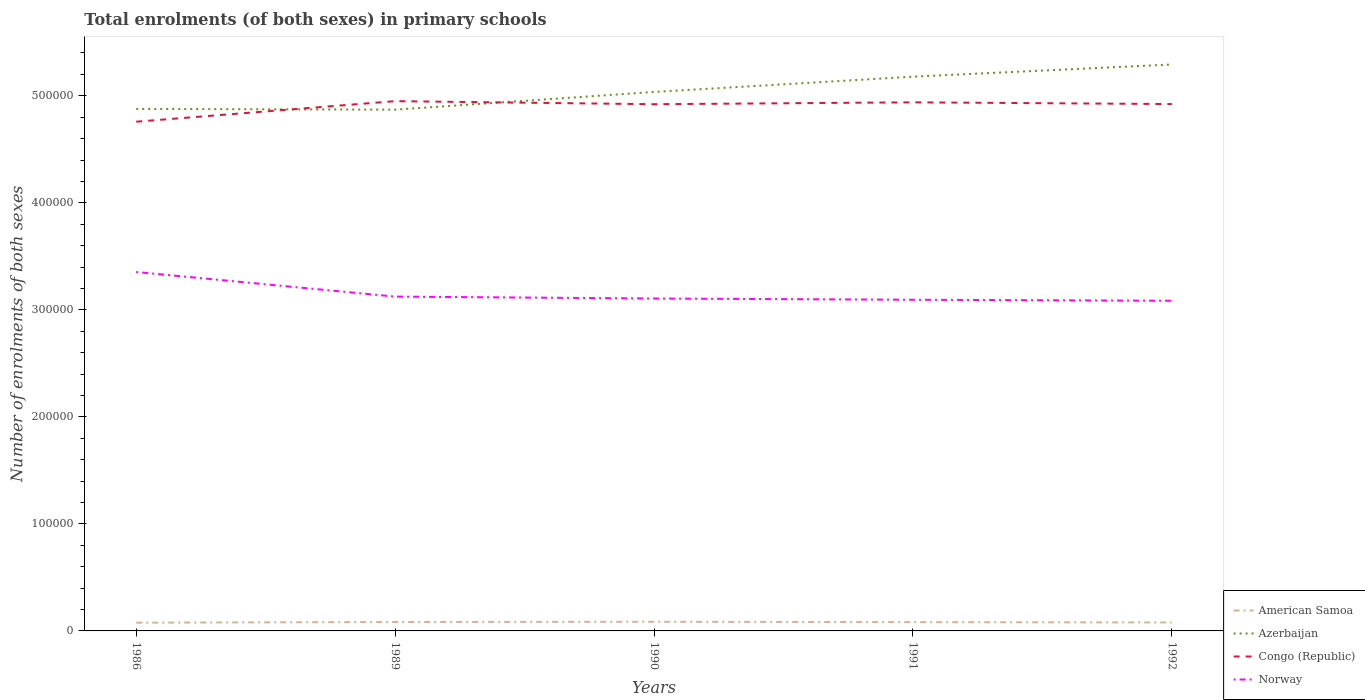Is the number of lines equal to the number of legend labels?
Ensure brevity in your answer.  Yes. Across all years, what is the maximum number of enrolments in primary schools in American Samoa?
Provide a succinct answer. 7704. What is the total number of enrolments in primary schools in Azerbaijan in the graph?
Ensure brevity in your answer.  -3.01e+04. What is the difference between the highest and the second highest number of enrolments in primary schools in American Samoa?
Keep it short and to the point. 870. Is the number of enrolments in primary schools in Congo (Republic) strictly greater than the number of enrolments in primary schools in Azerbaijan over the years?
Your response must be concise. No. How many lines are there?
Your response must be concise. 4. Where does the legend appear in the graph?
Offer a very short reply. Bottom right. How many legend labels are there?
Offer a terse response. 4. What is the title of the graph?
Your answer should be compact. Total enrolments (of both sexes) in primary schools. What is the label or title of the X-axis?
Provide a succinct answer. Years. What is the label or title of the Y-axis?
Give a very brief answer. Number of enrolments of both sexes. What is the Number of enrolments of both sexes in American Samoa in 1986?
Your answer should be very brief. 7704. What is the Number of enrolments of both sexes in Azerbaijan in 1986?
Your answer should be very brief. 4.88e+05. What is the Number of enrolments of both sexes of Congo (Republic) in 1986?
Your response must be concise. 4.76e+05. What is the Number of enrolments of both sexes of Norway in 1986?
Your response must be concise. 3.35e+05. What is the Number of enrolments of both sexes of American Samoa in 1989?
Give a very brief answer. 8308. What is the Number of enrolments of both sexes of Azerbaijan in 1989?
Ensure brevity in your answer.  4.87e+05. What is the Number of enrolments of both sexes of Congo (Republic) in 1989?
Provide a succinct answer. 4.95e+05. What is the Number of enrolments of both sexes in Norway in 1989?
Keep it short and to the point. 3.12e+05. What is the Number of enrolments of both sexes in American Samoa in 1990?
Offer a very short reply. 8574. What is the Number of enrolments of both sexes of Azerbaijan in 1990?
Keep it short and to the point. 5.04e+05. What is the Number of enrolments of both sexes of Congo (Republic) in 1990?
Provide a succinct answer. 4.92e+05. What is the Number of enrolments of both sexes in Norway in 1990?
Offer a terse response. 3.11e+05. What is the Number of enrolments of both sexes in American Samoa in 1991?
Ensure brevity in your answer.  8200. What is the Number of enrolments of both sexes of Azerbaijan in 1991?
Offer a terse response. 5.18e+05. What is the Number of enrolments of both sexes in Congo (Republic) in 1991?
Your response must be concise. 4.94e+05. What is the Number of enrolments of both sexes of Norway in 1991?
Offer a terse response. 3.09e+05. What is the Number of enrolments of both sexes of American Samoa in 1992?
Offer a very short reply. 7884. What is the Number of enrolments of both sexes in Azerbaijan in 1992?
Make the answer very short. 5.29e+05. What is the Number of enrolments of both sexes of Congo (Republic) in 1992?
Ensure brevity in your answer.  4.92e+05. What is the Number of enrolments of both sexes of Norway in 1992?
Your answer should be compact. 3.09e+05. Across all years, what is the maximum Number of enrolments of both sexes of American Samoa?
Make the answer very short. 8574. Across all years, what is the maximum Number of enrolments of both sexes in Azerbaijan?
Make the answer very short. 5.29e+05. Across all years, what is the maximum Number of enrolments of both sexes of Congo (Republic)?
Give a very brief answer. 4.95e+05. Across all years, what is the maximum Number of enrolments of both sexes in Norway?
Give a very brief answer. 3.35e+05. Across all years, what is the minimum Number of enrolments of both sexes in American Samoa?
Offer a terse response. 7704. Across all years, what is the minimum Number of enrolments of both sexes in Azerbaijan?
Your answer should be compact. 4.87e+05. Across all years, what is the minimum Number of enrolments of both sexes in Congo (Republic)?
Offer a very short reply. 4.76e+05. Across all years, what is the minimum Number of enrolments of both sexes in Norway?
Your answer should be compact. 3.09e+05. What is the total Number of enrolments of both sexes of American Samoa in the graph?
Your answer should be compact. 4.07e+04. What is the total Number of enrolments of both sexes in Azerbaijan in the graph?
Offer a very short reply. 2.53e+06. What is the total Number of enrolments of both sexes of Congo (Republic) in the graph?
Offer a very short reply. 2.45e+06. What is the total Number of enrolments of both sexes in Norway in the graph?
Offer a very short reply. 1.58e+06. What is the difference between the Number of enrolments of both sexes in American Samoa in 1986 and that in 1989?
Ensure brevity in your answer.  -604. What is the difference between the Number of enrolments of both sexes in Azerbaijan in 1986 and that in 1989?
Your answer should be compact. 695. What is the difference between the Number of enrolments of both sexes in Congo (Republic) in 1986 and that in 1989?
Keep it short and to the point. -1.92e+04. What is the difference between the Number of enrolments of both sexes of Norway in 1986 and that in 1989?
Offer a very short reply. 2.30e+04. What is the difference between the Number of enrolments of both sexes of American Samoa in 1986 and that in 1990?
Give a very brief answer. -870. What is the difference between the Number of enrolments of both sexes in Azerbaijan in 1986 and that in 1990?
Your answer should be compact. -1.58e+04. What is the difference between the Number of enrolments of both sexes of Congo (Republic) in 1986 and that in 1990?
Offer a very short reply. -1.63e+04. What is the difference between the Number of enrolments of both sexes of Norway in 1986 and that in 1990?
Your response must be concise. 2.48e+04. What is the difference between the Number of enrolments of both sexes in American Samoa in 1986 and that in 1991?
Offer a terse response. -496. What is the difference between the Number of enrolments of both sexes in Azerbaijan in 1986 and that in 1991?
Your response must be concise. -3.01e+04. What is the difference between the Number of enrolments of both sexes in Congo (Republic) in 1986 and that in 1991?
Ensure brevity in your answer.  -1.81e+04. What is the difference between the Number of enrolments of both sexes in Norway in 1986 and that in 1991?
Ensure brevity in your answer.  2.59e+04. What is the difference between the Number of enrolments of both sexes of American Samoa in 1986 and that in 1992?
Your answer should be very brief. -180. What is the difference between the Number of enrolments of both sexes of Azerbaijan in 1986 and that in 1992?
Give a very brief answer. -4.15e+04. What is the difference between the Number of enrolments of both sexes of Congo (Republic) in 1986 and that in 1992?
Give a very brief answer. -1.65e+04. What is the difference between the Number of enrolments of both sexes of Norway in 1986 and that in 1992?
Your answer should be compact. 2.69e+04. What is the difference between the Number of enrolments of both sexes of American Samoa in 1989 and that in 1990?
Keep it short and to the point. -266. What is the difference between the Number of enrolments of both sexes in Azerbaijan in 1989 and that in 1990?
Provide a succinct answer. -1.65e+04. What is the difference between the Number of enrolments of both sexes in Congo (Republic) in 1989 and that in 1990?
Your answer should be very brief. 2872. What is the difference between the Number of enrolments of both sexes in Norway in 1989 and that in 1990?
Your answer should be compact. 1784. What is the difference between the Number of enrolments of both sexes of American Samoa in 1989 and that in 1991?
Offer a very short reply. 108. What is the difference between the Number of enrolments of both sexes in Azerbaijan in 1989 and that in 1991?
Provide a short and direct response. -3.08e+04. What is the difference between the Number of enrolments of both sexes in Congo (Republic) in 1989 and that in 1991?
Ensure brevity in your answer.  1097. What is the difference between the Number of enrolments of both sexes in Norway in 1989 and that in 1991?
Your response must be concise. 2952. What is the difference between the Number of enrolments of both sexes in American Samoa in 1989 and that in 1992?
Provide a short and direct response. 424. What is the difference between the Number of enrolments of both sexes of Azerbaijan in 1989 and that in 1992?
Your answer should be very brief. -4.22e+04. What is the difference between the Number of enrolments of both sexes of Congo (Republic) in 1989 and that in 1992?
Provide a succinct answer. 2729. What is the difference between the Number of enrolments of both sexes of Norway in 1989 and that in 1992?
Your answer should be compact. 3868. What is the difference between the Number of enrolments of both sexes of American Samoa in 1990 and that in 1991?
Give a very brief answer. 374. What is the difference between the Number of enrolments of both sexes of Azerbaijan in 1990 and that in 1991?
Your response must be concise. -1.43e+04. What is the difference between the Number of enrolments of both sexes in Congo (Republic) in 1990 and that in 1991?
Your answer should be compact. -1775. What is the difference between the Number of enrolments of both sexes in Norway in 1990 and that in 1991?
Give a very brief answer. 1168. What is the difference between the Number of enrolments of both sexes in American Samoa in 1990 and that in 1992?
Make the answer very short. 690. What is the difference between the Number of enrolments of both sexes in Azerbaijan in 1990 and that in 1992?
Your response must be concise. -2.57e+04. What is the difference between the Number of enrolments of both sexes in Congo (Republic) in 1990 and that in 1992?
Offer a terse response. -143. What is the difference between the Number of enrolments of both sexes of Norway in 1990 and that in 1992?
Offer a terse response. 2084. What is the difference between the Number of enrolments of both sexes in American Samoa in 1991 and that in 1992?
Your answer should be compact. 316. What is the difference between the Number of enrolments of both sexes of Azerbaijan in 1991 and that in 1992?
Provide a short and direct response. -1.14e+04. What is the difference between the Number of enrolments of both sexes of Congo (Republic) in 1991 and that in 1992?
Offer a very short reply. 1632. What is the difference between the Number of enrolments of both sexes in Norway in 1991 and that in 1992?
Offer a terse response. 916. What is the difference between the Number of enrolments of both sexes of American Samoa in 1986 and the Number of enrolments of both sexes of Azerbaijan in 1989?
Keep it short and to the point. -4.79e+05. What is the difference between the Number of enrolments of both sexes in American Samoa in 1986 and the Number of enrolments of both sexes in Congo (Republic) in 1989?
Give a very brief answer. -4.87e+05. What is the difference between the Number of enrolments of both sexes of American Samoa in 1986 and the Number of enrolments of both sexes of Norway in 1989?
Offer a very short reply. -3.05e+05. What is the difference between the Number of enrolments of both sexes of Azerbaijan in 1986 and the Number of enrolments of both sexes of Congo (Republic) in 1989?
Your answer should be very brief. -7267. What is the difference between the Number of enrolments of both sexes of Azerbaijan in 1986 and the Number of enrolments of both sexes of Norway in 1989?
Your response must be concise. 1.75e+05. What is the difference between the Number of enrolments of both sexes in Congo (Republic) in 1986 and the Number of enrolments of both sexes in Norway in 1989?
Give a very brief answer. 1.63e+05. What is the difference between the Number of enrolments of both sexes in American Samoa in 1986 and the Number of enrolments of both sexes in Azerbaijan in 1990?
Provide a succinct answer. -4.96e+05. What is the difference between the Number of enrolments of both sexes in American Samoa in 1986 and the Number of enrolments of both sexes in Congo (Republic) in 1990?
Provide a succinct answer. -4.84e+05. What is the difference between the Number of enrolments of both sexes in American Samoa in 1986 and the Number of enrolments of both sexes in Norway in 1990?
Give a very brief answer. -3.03e+05. What is the difference between the Number of enrolments of both sexes of Azerbaijan in 1986 and the Number of enrolments of both sexes of Congo (Republic) in 1990?
Make the answer very short. -4395. What is the difference between the Number of enrolments of both sexes of Azerbaijan in 1986 and the Number of enrolments of both sexes of Norway in 1990?
Give a very brief answer. 1.77e+05. What is the difference between the Number of enrolments of both sexes in Congo (Republic) in 1986 and the Number of enrolments of both sexes in Norway in 1990?
Keep it short and to the point. 1.65e+05. What is the difference between the Number of enrolments of both sexes in American Samoa in 1986 and the Number of enrolments of both sexes in Azerbaijan in 1991?
Your response must be concise. -5.10e+05. What is the difference between the Number of enrolments of both sexes in American Samoa in 1986 and the Number of enrolments of both sexes in Congo (Republic) in 1991?
Your answer should be very brief. -4.86e+05. What is the difference between the Number of enrolments of both sexes of American Samoa in 1986 and the Number of enrolments of both sexes of Norway in 1991?
Make the answer very short. -3.02e+05. What is the difference between the Number of enrolments of both sexes of Azerbaijan in 1986 and the Number of enrolments of both sexes of Congo (Republic) in 1991?
Your response must be concise. -6170. What is the difference between the Number of enrolments of both sexes of Azerbaijan in 1986 and the Number of enrolments of both sexes of Norway in 1991?
Offer a very short reply. 1.78e+05. What is the difference between the Number of enrolments of both sexes of Congo (Republic) in 1986 and the Number of enrolments of both sexes of Norway in 1991?
Your answer should be very brief. 1.66e+05. What is the difference between the Number of enrolments of both sexes in American Samoa in 1986 and the Number of enrolments of both sexes in Azerbaijan in 1992?
Your answer should be very brief. -5.22e+05. What is the difference between the Number of enrolments of both sexes of American Samoa in 1986 and the Number of enrolments of both sexes of Congo (Republic) in 1992?
Your answer should be compact. -4.85e+05. What is the difference between the Number of enrolments of both sexes in American Samoa in 1986 and the Number of enrolments of both sexes in Norway in 1992?
Your response must be concise. -3.01e+05. What is the difference between the Number of enrolments of both sexes in Azerbaijan in 1986 and the Number of enrolments of both sexes in Congo (Republic) in 1992?
Give a very brief answer. -4538. What is the difference between the Number of enrolments of both sexes in Azerbaijan in 1986 and the Number of enrolments of both sexes in Norway in 1992?
Provide a short and direct response. 1.79e+05. What is the difference between the Number of enrolments of both sexes of Congo (Republic) in 1986 and the Number of enrolments of both sexes of Norway in 1992?
Make the answer very short. 1.67e+05. What is the difference between the Number of enrolments of both sexes of American Samoa in 1989 and the Number of enrolments of both sexes of Azerbaijan in 1990?
Give a very brief answer. -4.95e+05. What is the difference between the Number of enrolments of both sexes in American Samoa in 1989 and the Number of enrolments of both sexes in Congo (Republic) in 1990?
Your response must be concise. -4.84e+05. What is the difference between the Number of enrolments of both sexes of American Samoa in 1989 and the Number of enrolments of both sexes of Norway in 1990?
Your answer should be very brief. -3.02e+05. What is the difference between the Number of enrolments of both sexes in Azerbaijan in 1989 and the Number of enrolments of both sexes in Congo (Republic) in 1990?
Make the answer very short. -5090. What is the difference between the Number of enrolments of both sexes in Azerbaijan in 1989 and the Number of enrolments of both sexes in Norway in 1990?
Offer a very short reply. 1.76e+05. What is the difference between the Number of enrolments of both sexes in Congo (Republic) in 1989 and the Number of enrolments of both sexes in Norway in 1990?
Offer a terse response. 1.84e+05. What is the difference between the Number of enrolments of both sexes in American Samoa in 1989 and the Number of enrolments of both sexes in Azerbaijan in 1991?
Ensure brevity in your answer.  -5.10e+05. What is the difference between the Number of enrolments of both sexes in American Samoa in 1989 and the Number of enrolments of both sexes in Congo (Republic) in 1991?
Offer a terse response. -4.86e+05. What is the difference between the Number of enrolments of both sexes of American Samoa in 1989 and the Number of enrolments of both sexes of Norway in 1991?
Keep it short and to the point. -3.01e+05. What is the difference between the Number of enrolments of both sexes of Azerbaijan in 1989 and the Number of enrolments of both sexes of Congo (Republic) in 1991?
Offer a very short reply. -6865. What is the difference between the Number of enrolments of both sexes of Azerbaijan in 1989 and the Number of enrolments of both sexes of Norway in 1991?
Keep it short and to the point. 1.78e+05. What is the difference between the Number of enrolments of both sexes of Congo (Republic) in 1989 and the Number of enrolments of both sexes of Norway in 1991?
Ensure brevity in your answer.  1.86e+05. What is the difference between the Number of enrolments of both sexes in American Samoa in 1989 and the Number of enrolments of both sexes in Azerbaijan in 1992?
Make the answer very short. -5.21e+05. What is the difference between the Number of enrolments of both sexes in American Samoa in 1989 and the Number of enrolments of both sexes in Congo (Republic) in 1992?
Ensure brevity in your answer.  -4.84e+05. What is the difference between the Number of enrolments of both sexes of American Samoa in 1989 and the Number of enrolments of both sexes of Norway in 1992?
Your answer should be compact. -3.00e+05. What is the difference between the Number of enrolments of both sexes in Azerbaijan in 1989 and the Number of enrolments of both sexes in Congo (Republic) in 1992?
Offer a very short reply. -5233. What is the difference between the Number of enrolments of both sexes in Azerbaijan in 1989 and the Number of enrolments of both sexes in Norway in 1992?
Offer a terse response. 1.79e+05. What is the difference between the Number of enrolments of both sexes of Congo (Republic) in 1989 and the Number of enrolments of both sexes of Norway in 1992?
Make the answer very short. 1.86e+05. What is the difference between the Number of enrolments of both sexes of American Samoa in 1990 and the Number of enrolments of both sexes of Azerbaijan in 1991?
Make the answer very short. -5.09e+05. What is the difference between the Number of enrolments of both sexes in American Samoa in 1990 and the Number of enrolments of both sexes in Congo (Republic) in 1991?
Your response must be concise. -4.85e+05. What is the difference between the Number of enrolments of both sexes in American Samoa in 1990 and the Number of enrolments of both sexes in Norway in 1991?
Provide a succinct answer. -3.01e+05. What is the difference between the Number of enrolments of both sexes of Azerbaijan in 1990 and the Number of enrolments of both sexes of Congo (Republic) in 1991?
Provide a short and direct response. 9680. What is the difference between the Number of enrolments of both sexes of Azerbaijan in 1990 and the Number of enrolments of both sexes of Norway in 1991?
Keep it short and to the point. 1.94e+05. What is the difference between the Number of enrolments of both sexes in Congo (Republic) in 1990 and the Number of enrolments of both sexes in Norway in 1991?
Make the answer very short. 1.83e+05. What is the difference between the Number of enrolments of both sexes of American Samoa in 1990 and the Number of enrolments of both sexes of Azerbaijan in 1992?
Ensure brevity in your answer.  -5.21e+05. What is the difference between the Number of enrolments of both sexes of American Samoa in 1990 and the Number of enrolments of both sexes of Congo (Republic) in 1992?
Provide a succinct answer. -4.84e+05. What is the difference between the Number of enrolments of both sexes in American Samoa in 1990 and the Number of enrolments of both sexes in Norway in 1992?
Make the answer very short. -3.00e+05. What is the difference between the Number of enrolments of both sexes in Azerbaijan in 1990 and the Number of enrolments of both sexes in Congo (Republic) in 1992?
Ensure brevity in your answer.  1.13e+04. What is the difference between the Number of enrolments of both sexes in Azerbaijan in 1990 and the Number of enrolments of both sexes in Norway in 1992?
Your answer should be compact. 1.95e+05. What is the difference between the Number of enrolments of both sexes of Congo (Republic) in 1990 and the Number of enrolments of both sexes of Norway in 1992?
Make the answer very short. 1.84e+05. What is the difference between the Number of enrolments of both sexes in American Samoa in 1991 and the Number of enrolments of both sexes in Azerbaijan in 1992?
Keep it short and to the point. -5.21e+05. What is the difference between the Number of enrolments of both sexes in American Samoa in 1991 and the Number of enrolments of both sexes in Congo (Republic) in 1992?
Give a very brief answer. -4.84e+05. What is the difference between the Number of enrolments of both sexes of American Samoa in 1991 and the Number of enrolments of both sexes of Norway in 1992?
Offer a very short reply. -3.00e+05. What is the difference between the Number of enrolments of both sexes in Azerbaijan in 1991 and the Number of enrolments of both sexes in Congo (Republic) in 1992?
Keep it short and to the point. 2.56e+04. What is the difference between the Number of enrolments of both sexes in Azerbaijan in 1991 and the Number of enrolments of both sexes in Norway in 1992?
Offer a very short reply. 2.09e+05. What is the difference between the Number of enrolments of both sexes of Congo (Republic) in 1991 and the Number of enrolments of both sexes of Norway in 1992?
Provide a succinct answer. 1.85e+05. What is the average Number of enrolments of both sexes of American Samoa per year?
Offer a very short reply. 8134. What is the average Number of enrolments of both sexes in Azerbaijan per year?
Provide a succinct answer. 5.05e+05. What is the average Number of enrolments of both sexes in Congo (Republic) per year?
Provide a succinct answer. 4.90e+05. What is the average Number of enrolments of both sexes in Norway per year?
Ensure brevity in your answer.  3.15e+05. In the year 1986, what is the difference between the Number of enrolments of both sexes of American Samoa and Number of enrolments of both sexes of Azerbaijan?
Ensure brevity in your answer.  -4.80e+05. In the year 1986, what is the difference between the Number of enrolments of both sexes in American Samoa and Number of enrolments of both sexes in Congo (Republic)?
Provide a succinct answer. -4.68e+05. In the year 1986, what is the difference between the Number of enrolments of both sexes in American Samoa and Number of enrolments of both sexes in Norway?
Offer a terse response. -3.28e+05. In the year 1986, what is the difference between the Number of enrolments of both sexes of Azerbaijan and Number of enrolments of both sexes of Congo (Republic)?
Keep it short and to the point. 1.19e+04. In the year 1986, what is the difference between the Number of enrolments of both sexes in Azerbaijan and Number of enrolments of both sexes in Norway?
Your response must be concise. 1.52e+05. In the year 1986, what is the difference between the Number of enrolments of both sexes in Congo (Republic) and Number of enrolments of both sexes in Norway?
Keep it short and to the point. 1.40e+05. In the year 1989, what is the difference between the Number of enrolments of both sexes of American Samoa and Number of enrolments of both sexes of Azerbaijan?
Provide a short and direct response. -4.79e+05. In the year 1989, what is the difference between the Number of enrolments of both sexes of American Samoa and Number of enrolments of both sexes of Congo (Republic)?
Your answer should be compact. -4.87e+05. In the year 1989, what is the difference between the Number of enrolments of both sexes of American Samoa and Number of enrolments of both sexes of Norway?
Your response must be concise. -3.04e+05. In the year 1989, what is the difference between the Number of enrolments of both sexes in Azerbaijan and Number of enrolments of both sexes in Congo (Republic)?
Offer a very short reply. -7962. In the year 1989, what is the difference between the Number of enrolments of both sexes in Azerbaijan and Number of enrolments of both sexes in Norway?
Ensure brevity in your answer.  1.75e+05. In the year 1989, what is the difference between the Number of enrolments of both sexes of Congo (Republic) and Number of enrolments of both sexes of Norway?
Make the answer very short. 1.83e+05. In the year 1990, what is the difference between the Number of enrolments of both sexes of American Samoa and Number of enrolments of both sexes of Azerbaijan?
Provide a short and direct response. -4.95e+05. In the year 1990, what is the difference between the Number of enrolments of both sexes of American Samoa and Number of enrolments of both sexes of Congo (Republic)?
Offer a terse response. -4.84e+05. In the year 1990, what is the difference between the Number of enrolments of both sexes in American Samoa and Number of enrolments of both sexes in Norway?
Your response must be concise. -3.02e+05. In the year 1990, what is the difference between the Number of enrolments of both sexes in Azerbaijan and Number of enrolments of both sexes in Congo (Republic)?
Offer a terse response. 1.15e+04. In the year 1990, what is the difference between the Number of enrolments of both sexes of Azerbaijan and Number of enrolments of both sexes of Norway?
Provide a succinct answer. 1.93e+05. In the year 1990, what is the difference between the Number of enrolments of both sexes in Congo (Republic) and Number of enrolments of both sexes in Norway?
Keep it short and to the point. 1.82e+05. In the year 1991, what is the difference between the Number of enrolments of both sexes in American Samoa and Number of enrolments of both sexes in Azerbaijan?
Offer a terse response. -5.10e+05. In the year 1991, what is the difference between the Number of enrolments of both sexes of American Samoa and Number of enrolments of both sexes of Congo (Republic)?
Ensure brevity in your answer.  -4.86e+05. In the year 1991, what is the difference between the Number of enrolments of both sexes of American Samoa and Number of enrolments of both sexes of Norway?
Your answer should be very brief. -3.01e+05. In the year 1991, what is the difference between the Number of enrolments of both sexes of Azerbaijan and Number of enrolments of both sexes of Congo (Republic)?
Your answer should be compact. 2.40e+04. In the year 1991, what is the difference between the Number of enrolments of both sexes of Azerbaijan and Number of enrolments of both sexes of Norway?
Ensure brevity in your answer.  2.08e+05. In the year 1991, what is the difference between the Number of enrolments of both sexes in Congo (Republic) and Number of enrolments of both sexes in Norway?
Your answer should be very brief. 1.84e+05. In the year 1992, what is the difference between the Number of enrolments of both sexes of American Samoa and Number of enrolments of both sexes of Azerbaijan?
Provide a short and direct response. -5.21e+05. In the year 1992, what is the difference between the Number of enrolments of both sexes of American Samoa and Number of enrolments of both sexes of Congo (Republic)?
Your response must be concise. -4.84e+05. In the year 1992, what is the difference between the Number of enrolments of both sexes of American Samoa and Number of enrolments of both sexes of Norway?
Your answer should be compact. -3.01e+05. In the year 1992, what is the difference between the Number of enrolments of both sexes of Azerbaijan and Number of enrolments of both sexes of Congo (Republic)?
Make the answer very short. 3.70e+04. In the year 1992, what is the difference between the Number of enrolments of both sexes in Azerbaijan and Number of enrolments of both sexes in Norway?
Keep it short and to the point. 2.21e+05. In the year 1992, what is the difference between the Number of enrolments of both sexes of Congo (Republic) and Number of enrolments of both sexes of Norway?
Your answer should be very brief. 1.84e+05. What is the ratio of the Number of enrolments of both sexes of American Samoa in 1986 to that in 1989?
Offer a terse response. 0.93. What is the ratio of the Number of enrolments of both sexes of Congo (Republic) in 1986 to that in 1989?
Your answer should be very brief. 0.96. What is the ratio of the Number of enrolments of both sexes of Norway in 1986 to that in 1989?
Make the answer very short. 1.07. What is the ratio of the Number of enrolments of both sexes of American Samoa in 1986 to that in 1990?
Give a very brief answer. 0.9. What is the ratio of the Number of enrolments of both sexes of Azerbaijan in 1986 to that in 1990?
Make the answer very short. 0.97. What is the ratio of the Number of enrolments of both sexes of Congo (Republic) in 1986 to that in 1990?
Ensure brevity in your answer.  0.97. What is the ratio of the Number of enrolments of both sexes of Norway in 1986 to that in 1990?
Ensure brevity in your answer.  1.08. What is the ratio of the Number of enrolments of both sexes in American Samoa in 1986 to that in 1991?
Offer a very short reply. 0.94. What is the ratio of the Number of enrolments of both sexes in Azerbaijan in 1986 to that in 1991?
Provide a succinct answer. 0.94. What is the ratio of the Number of enrolments of both sexes in Congo (Republic) in 1986 to that in 1991?
Your answer should be compact. 0.96. What is the ratio of the Number of enrolments of both sexes of Norway in 1986 to that in 1991?
Give a very brief answer. 1.08. What is the ratio of the Number of enrolments of both sexes in American Samoa in 1986 to that in 1992?
Ensure brevity in your answer.  0.98. What is the ratio of the Number of enrolments of both sexes in Azerbaijan in 1986 to that in 1992?
Make the answer very short. 0.92. What is the ratio of the Number of enrolments of both sexes in Congo (Republic) in 1986 to that in 1992?
Offer a very short reply. 0.97. What is the ratio of the Number of enrolments of both sexes of Norway in 1986 to that in 1992?
Provide a succinct answer. 1.09. What is the ratio of the Number of enrolments of both sexes in American Samoa in 1989 to that in 1990?
Give a very brief answer. 0.97. What is the ratio of the Number of enrolments of both sexes of Azerbaijan in 1989 to that in 1990?
Your answer should be compact. 0.97. What is the ratio of the Number of enrolments of both sexes of Congo (Republic) in 1989 to that in 1990?
Give a very brief answer. 1.01. What is the ratio of the Number of enrolments of both sexes of Norway in 1989 to that in 1990?
Keep it short and to the point. 1.01. What is the ratio of the Number of enrolments of both sexes of American Samoa in 1989 to that in 1991?
Your answer should be compact. 1.01. What is the ratio of the Number of enrolments of both sexes in Azerbaijan in 1989 to that in 1991?
Keep it short and to the point. 0.94. What is the ratio of the Number of enrolments of both sexes of Congo (Republic) in 1989 to that in 1991?
Make the answer very short. 1. What is the ratio of the Number of enrolments of both sexes in Norway in 1989 to that in 1991?
Provide a short and direct response. 1.01. What is the ratio of the Number of enrolments of both sexes in American Samoa in 1989 to that in 1992?
Make the answer very short. 1.05. What is the ratio of the Number of enrolments of both sexes of Azerbaijan in 1989 to that in 1992?
Your response must be concise. 0.92. What is the ratio of the Number of enrolments of both sexes in Norway in 1989 to that in 1992?
Provide a succinct answer. 1.01. What is the ratio of the Number of enrolments of both sexes in American Samoa in 1990 to that in 1991?
Your answer should be compact. 1.05. What is the ratio of the Number of enrolments of both sexes in Azerbaijan in 1990 to that in 1991?
Your response must be concise. 0.97. What is the ratio of the Number of enrolments of both sexes in Congo (Republic) in 1990 to that in 1991?
Provide a short and direct response. 1. What is the ratio of the Number of enrolments of both sexes of American Samoa in 1990 to that in 1992?
Make the answer very short. 1.09. What is the ratio of the Number of enrolments of both sexes in Azerbaijan in 1990 to that in 1992?
Offer a terse response. 0.95. What is the ratio of the Number of enrolments of both sexes in Congo (Republic) in 1990 to that in 1992?
Make the answer very short. 1. What is the ratio of the Number of enrolments of both sexes in Norway in 1990 to that in 1992?
Give a very brief answer. 1.01. What is the ratio of the Number of enrolments of both sexes in American Samoa in 1991 to that in 1992?
Provide a short and direct response. 1.04. What is the ratio of the Number of enrolments of both sexes of Azerbaijan in 1991 to that in 1992?
Your response must be concise. 0.98. What is the ratio of the Number of enrolments of both sexes of Norway in 1991 to that in 1992?
Your answer should be very brief. 1. What is the difference between the highest and the second highest Number of enrolments of both sexes in American Samoa?
Your response must be concise. 266. What is the difference between the highest and the second highest Number of enrolments of both sexes in Azerbaijan?
Give a very brief answer. 1.14e+04. What is the difference between the highest and the second highest Number of enrolments of both sexes of Congo (Republic)?
Provide a succinct answer. 1097. What is the difference between the highest and the second highest Number of enrolments of both sexes of Norway?
Ensure brevity in your answer.  2.30e+04. What is the difference between the highest and the lowest Number of enrolments of both sexes in American Samoa?
Give a very brief answer. 870. What is the difference between the highest and the lowest Number of enrolments of both sexes in Azerbaijan?
Make the answer very short. 4.22e+04. What is the difference between the highest and the lowest Number of enrolments of both sexes of Congo (Republic)?
Your answer should be very brief. 1.92e+04. What is the difference between the highest and the lowest Number of enrolments of both sexes of Norway?
Offer a very short reply. 2.69e+04. 